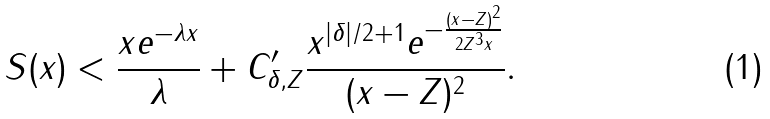Convert formula to latex. <formula><loc_0><loc_0><loc_500><loc_500>S ( x ) < \frac { x e ^ { - \lambda x } } { \lambda } + C _ { \delta , Z } ^ { \prime } \frac { x ^ { | \delta | / 2 + 1 } e ^ { - \frac { ( x - Z ) ^ { 2 } } { 2 Z ^ { 3 } x } } } { ( x - Z ) ^ { 2 } } .</formula> 